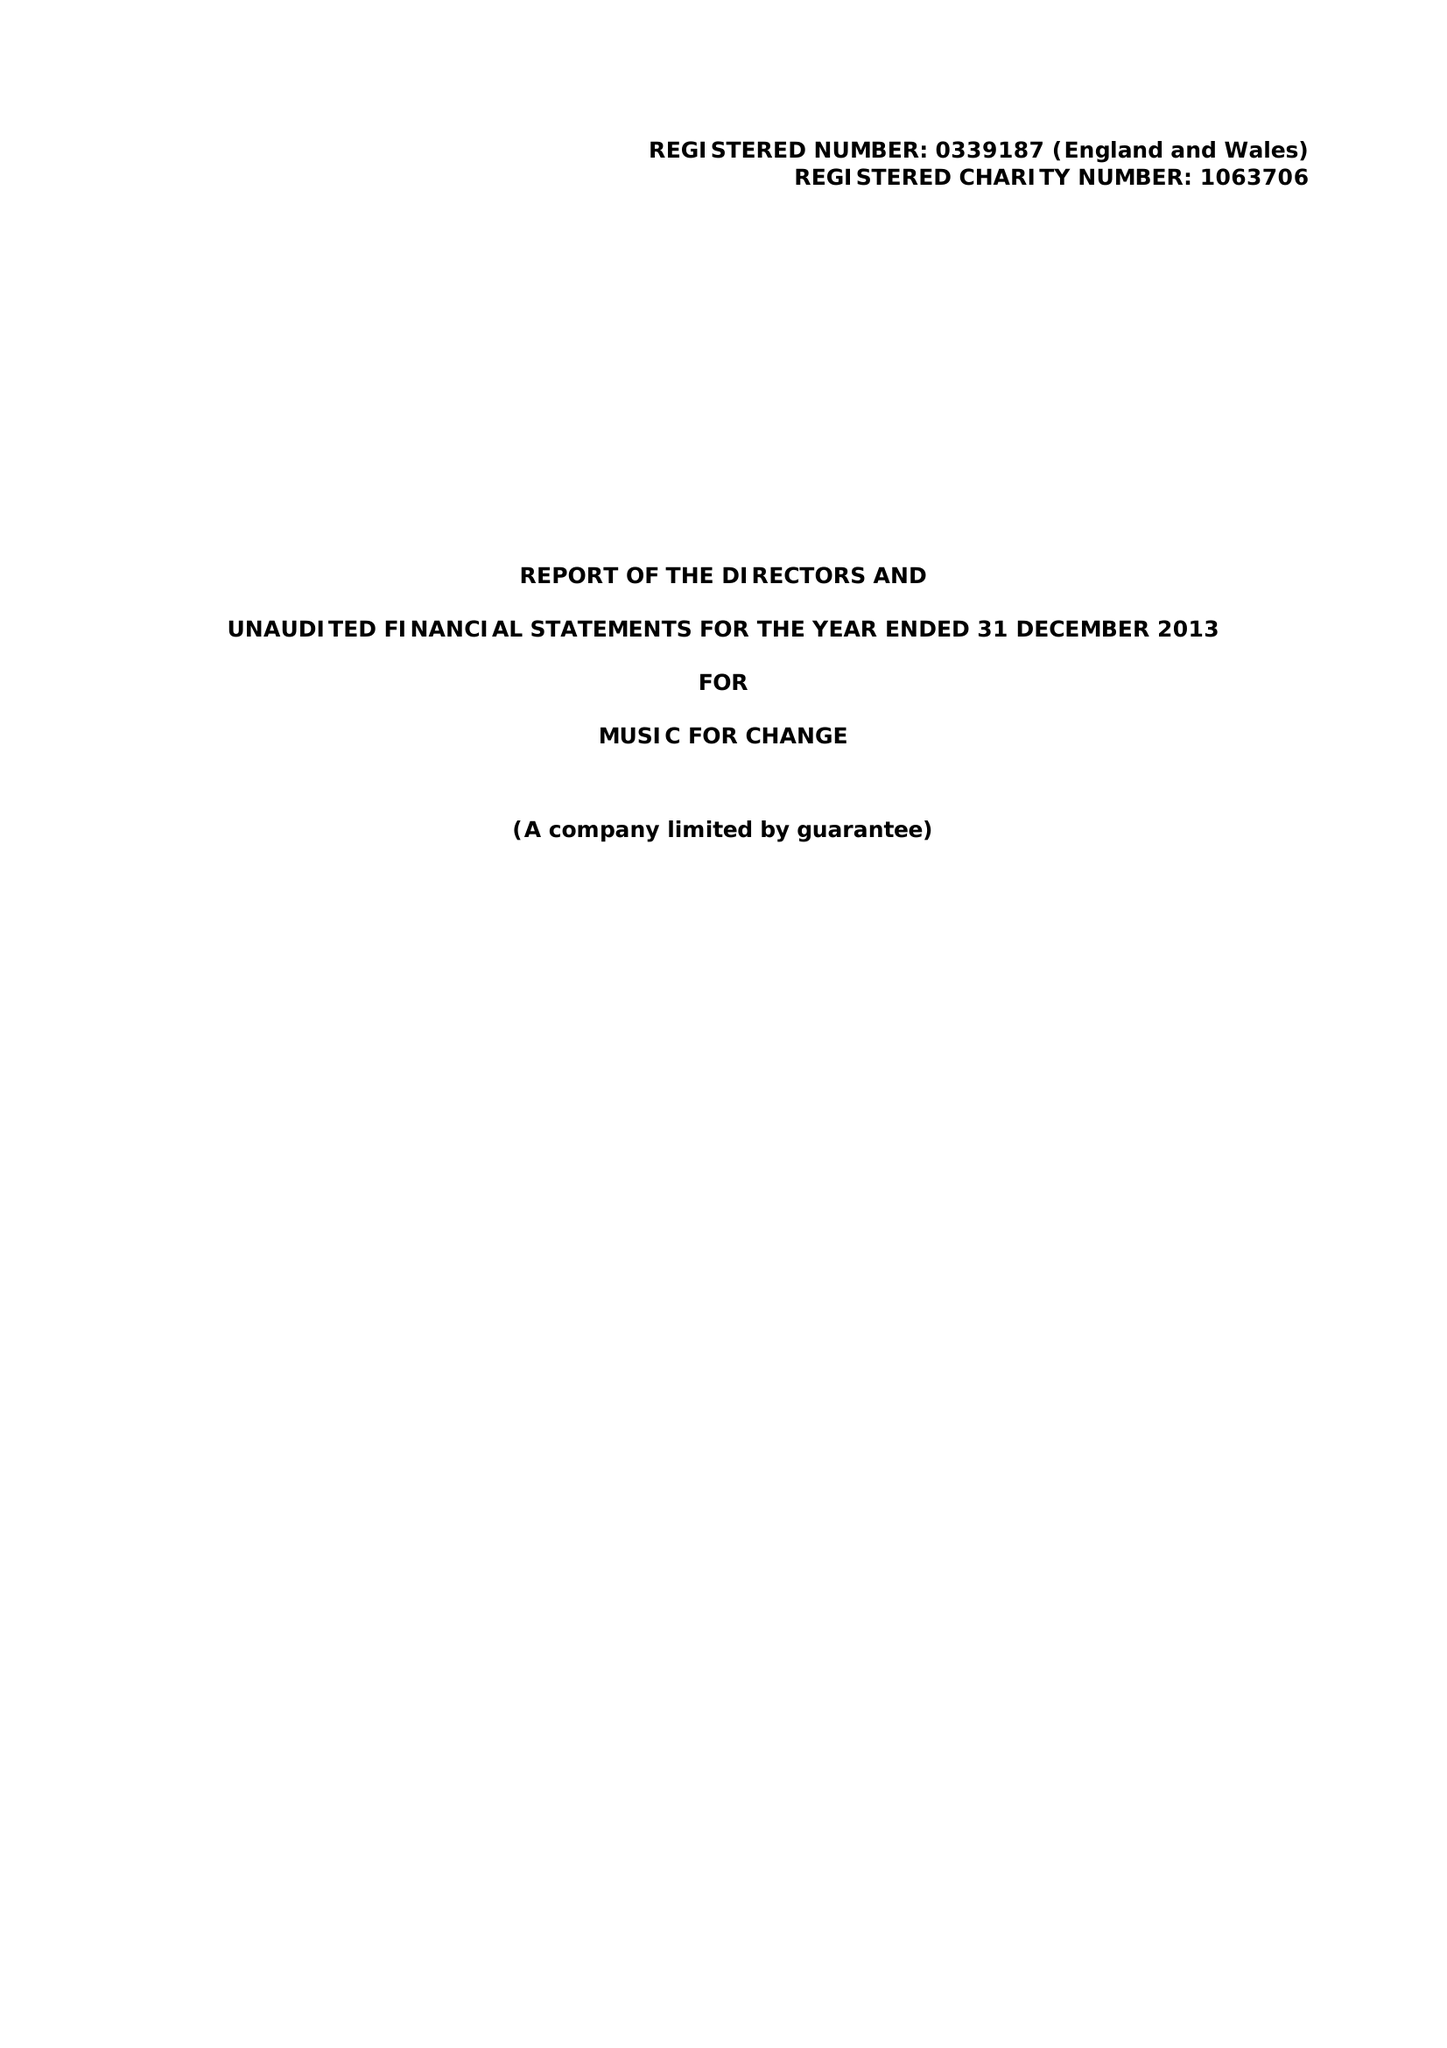What is the value for the income_annually_in_british_pounds?
Answer the question using a single word or phrase. 138788.00 